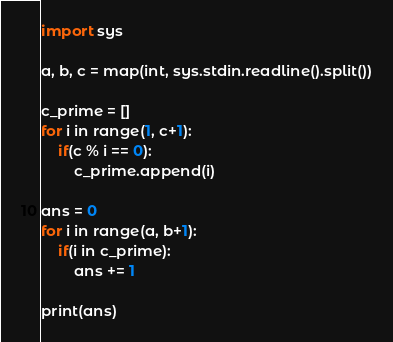<code> <loc_0><loc_0><loc_500><loc_500><_Python_>import sys

a, b, c = map(int, sys.stdin.readline().split())

c_prime = []
for i in range(1, c+1):
    if(c % i == 0):
        c_prime.append(i)

ans = 0
for i in range(a, b+1):
    if(i in c_prime):
        ans += 1

print(ans)</code> 